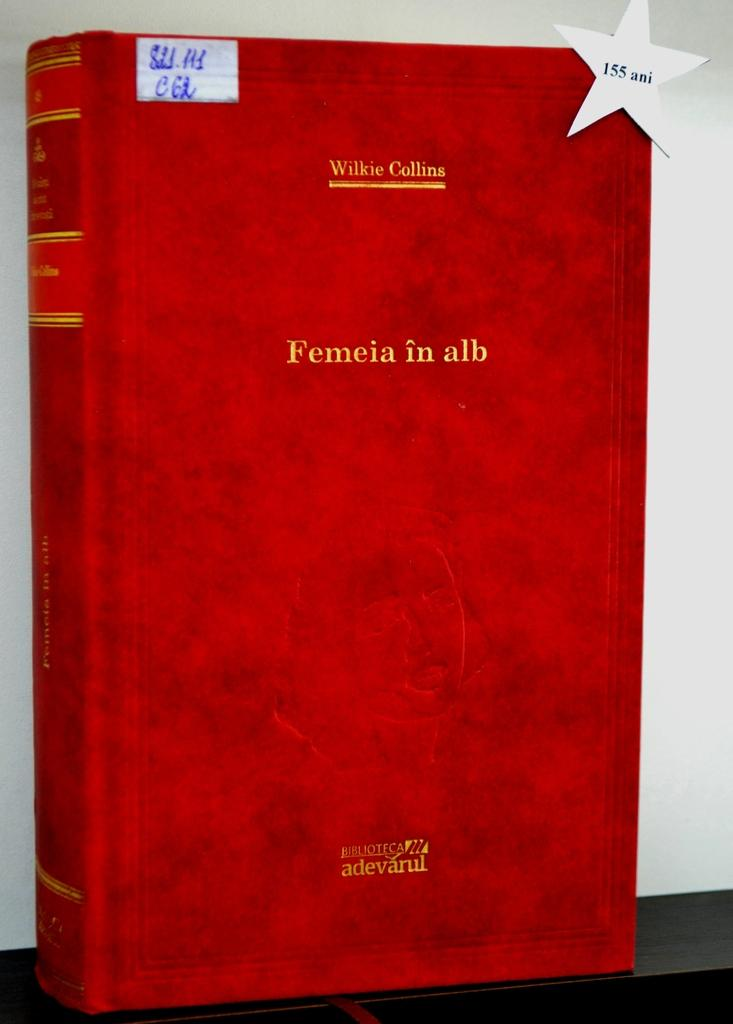<image>
Present a compact description of the photo's key features. A red leatherbound book that says Femeia in alb. 